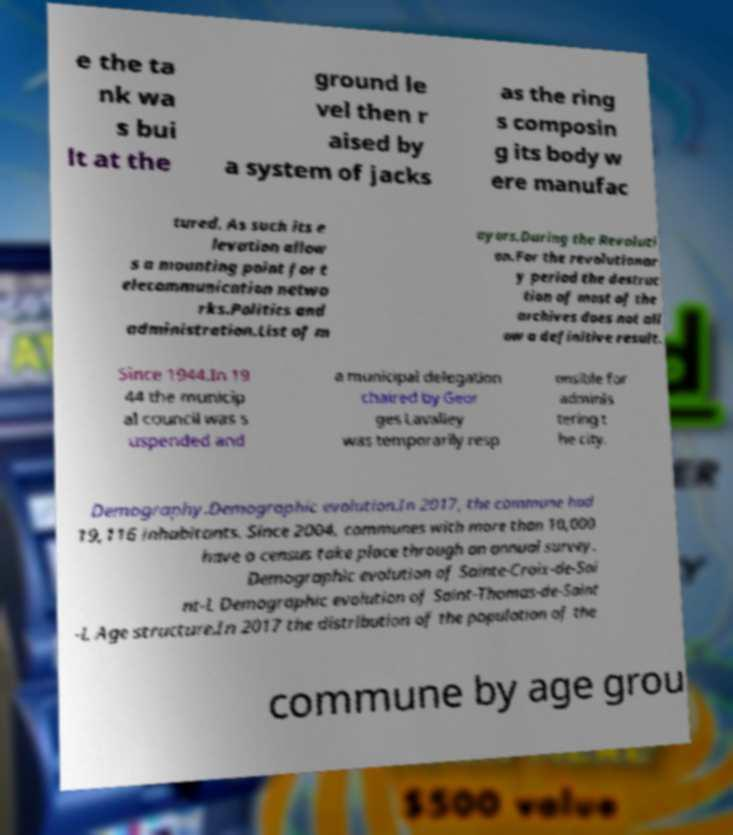Could you assist in decoding the text presented in this image and type it out clearly? e the ta nk wa s bui lt at the ground le vel then r aised by a system of jacks as the ring s composin g its body w ere manufac tured. As such its e levation allow s a mounting point for t elecommunication netwo rks.Politics and administration.List of m ayors.During the Revoluti on.For the revolutionar y period the destruc tion of most of the archives does not all ow a definitive result. Since 1944.In 19 44 the municip al council was s uspended and a municipal delegation chaired by Geor ges Lavalley was temporarily resp onsible for adminis tering t he city. Demography.Demographic evolution.In 2017, the commune had 19,116 inhabitants. Since 2004, communes with more than 10,000 have a census take place through an annual survey. Demographic evolution of Sainte-Croix-de-Sai nt-L Demographic evolution of Saint-Thomas-de-Saint -L Age structure.In 2017 the distribution of the population of the commune by age grou 